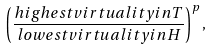<formula> <loc_0><loc_0><loc_500><loc_500>\left ( \frac { h i g h e s t v i r t u a l i t y i n T } { l o w e s t v i r t u a l i t y i n H } \right ) ^ { p } ,</formula> 